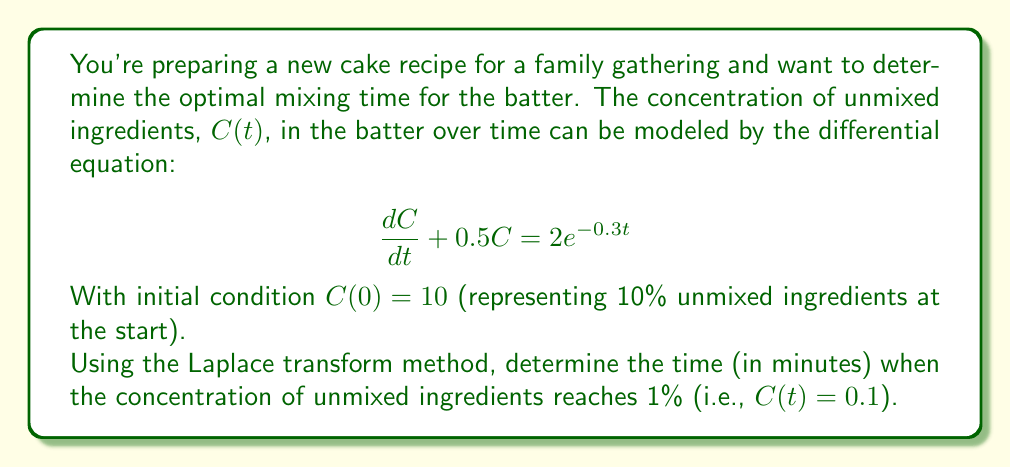Help me with this question. Let's solve this problem step by step using the Laplace transform method:

1) Take the Laplace transform of both sides of the differential equation:
   $$\mathcal{L}\{\frac{dC}{dt} + 0.5C\} = \mathcal{L}\{2e^{-0.3t}\}$$

2) Using Laplace transform properties:
   $$s\mathcal{L}\{C\} - C(0) + 0.5\mathcal{L}\{C\} = \frac{2}{s+0.3}$$

3) Let $\mathcal{L}\{C\} = F(s)$. Substituting the initial condition:
   $$sF(s) - 10 + 0.5F(s) = \frac{2}{s+0.3}$$

4) Solve for $F(s)$:
   $$F(s) = \frac{10}{s+0.5} + \frac{2}{(s+0.5)(s+0.3)}$$

5) Perform partial fraction decomposition:
   $$F(s) = \frac{10}{s+0.5} + \frac{A}{s+0.5} + \frac{B}{s+0.3}$$
   where $A = \frac{2}{0.2} = 10$ and $B = \frac{-2}{0.2} = -10$

6) Take the inverse Laplace transform:
   $$C(t) = 10e^{-0.5t} + 10e^{-0.5t} - 10e^{-0.3t}$$

7) Simplify:
   $$C(t) = 20e^{-0.5t} - 10e^{-0.3t}$$

8) To find when $C(t) = 0.1$, solve:
   $$0.1 = 20e^{-0.5t} - 10e^{-0.3t}$$

9) This transcendental equation can be solved numerically. Using a numerical method (e.g., Newton-Raphson), we find:
   $$t \approx 8.76 \text{ minutes}$$
Answer: The optimal mixing time for the cake batter is approximately 8.76 minutes. 